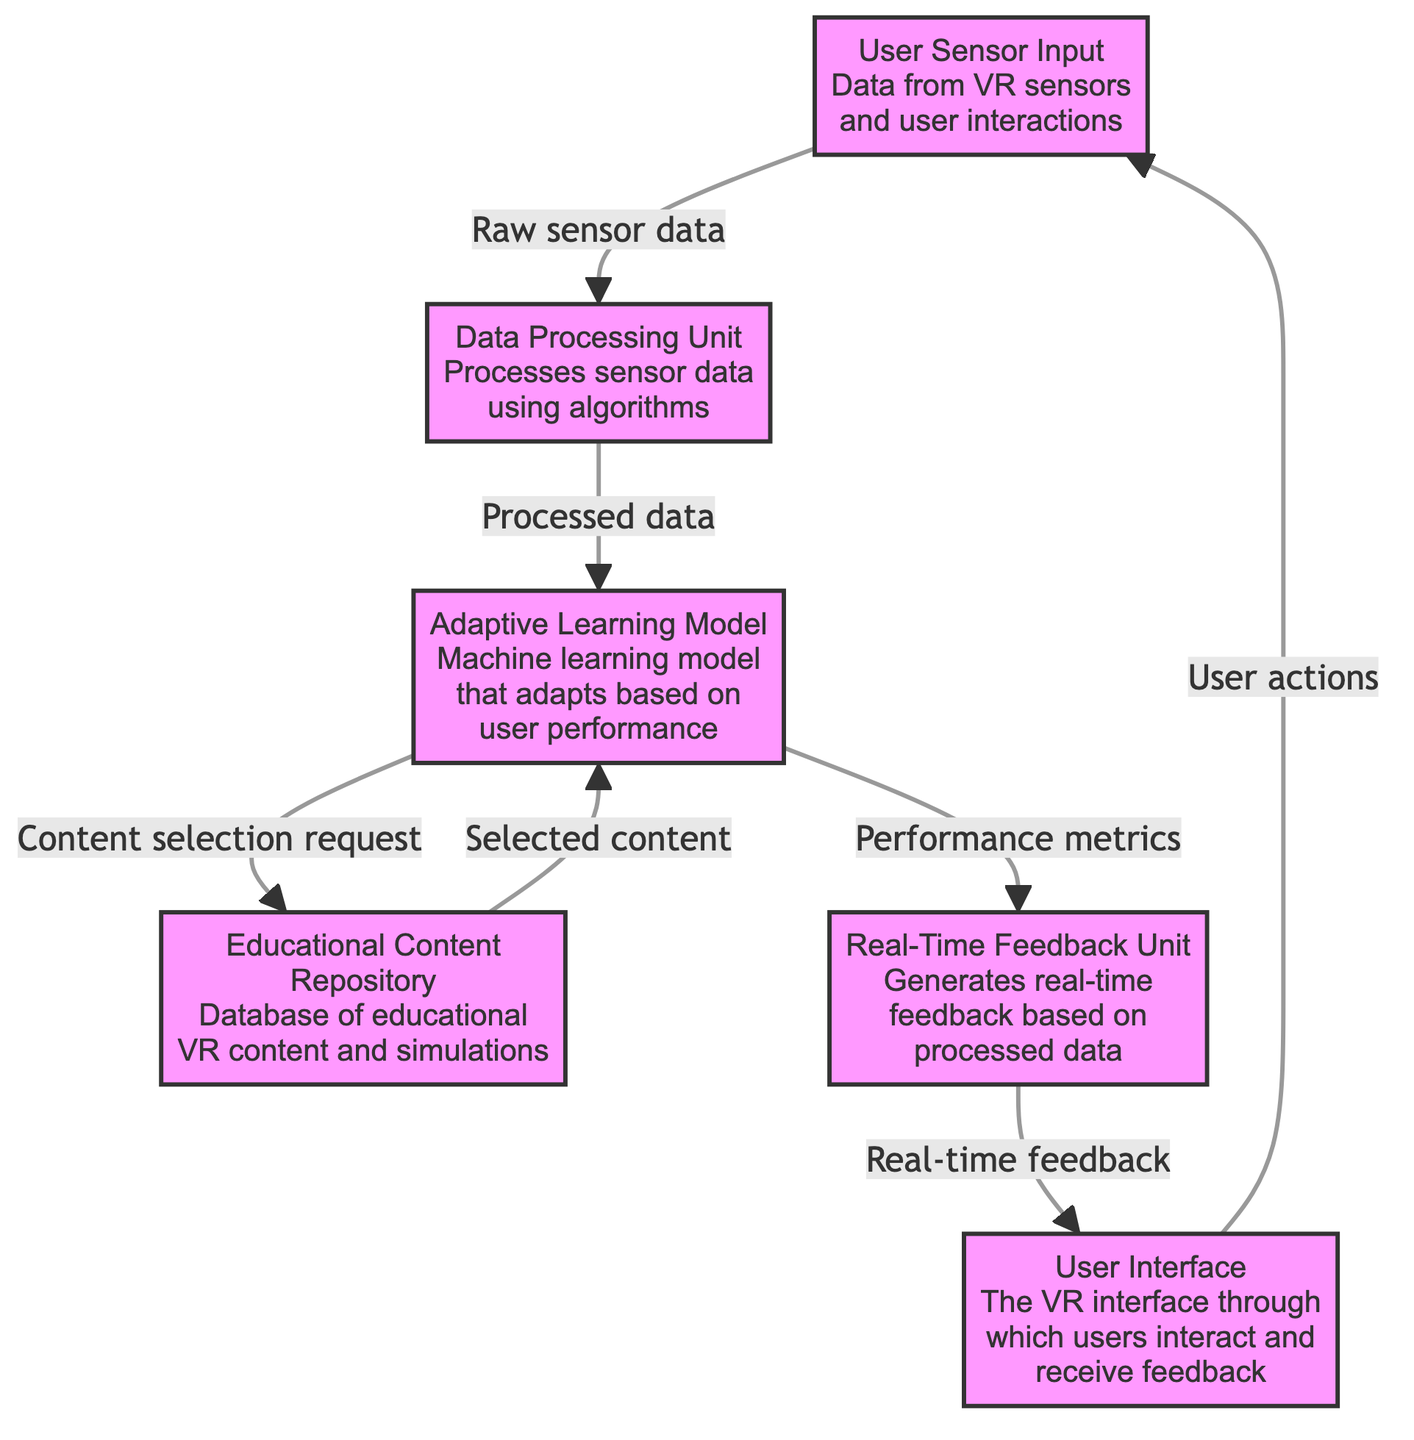What is the first node in the flowchart? The first node in the flowchart is labeled "User Sensor Input," representing the starting point where data from VR sensors and user interactions are collected.
Answer: User Sensor Input Which unit processes the raw sensor data? The data processing unit is the component responsible for processing the raw sensor data using algorithms.
Answer: Data Processing Unit How many nodes are present in the diagram? The diagram features six distinct nodes, each representing a component involved in the adaptive VR system architecture.
Answer: Six What type of feedback does the feedback unit generate? The feedback unit generates real-time feedback based on the processed data received from the adaptive learning model.
Answer: Real-time feedback What does the adaptive learning model send to the feedback unit? The adaptive learning model sends performance metrics to the feedback unit, which are used to generate the real-time feedback for the user interface.
Answer: Performance metrics Which component requests content selection? The adaptive learning model makes content selection requests to the educational content repository based on user performance needs.
Answer: Adaptive Learning Model What is the connection between the user interface and user sensor input? The user interface connects back to the user sensor input by sending user actions, which informs the system of how the user interacts with the VR environment.
Answer: User actions What is the role of the educational content repository in the diagram? The educational content repository serves as the database for educational VR content and simulations, supplying selected content to the adaptive learning model based on requests.
Answer: Database of educational VR content and simulations What does the data processing unit output? The data processing unit outputs processed data that is then sent to the adaptive learning model for further evaluation and adaptation.
Answer: Processed data 